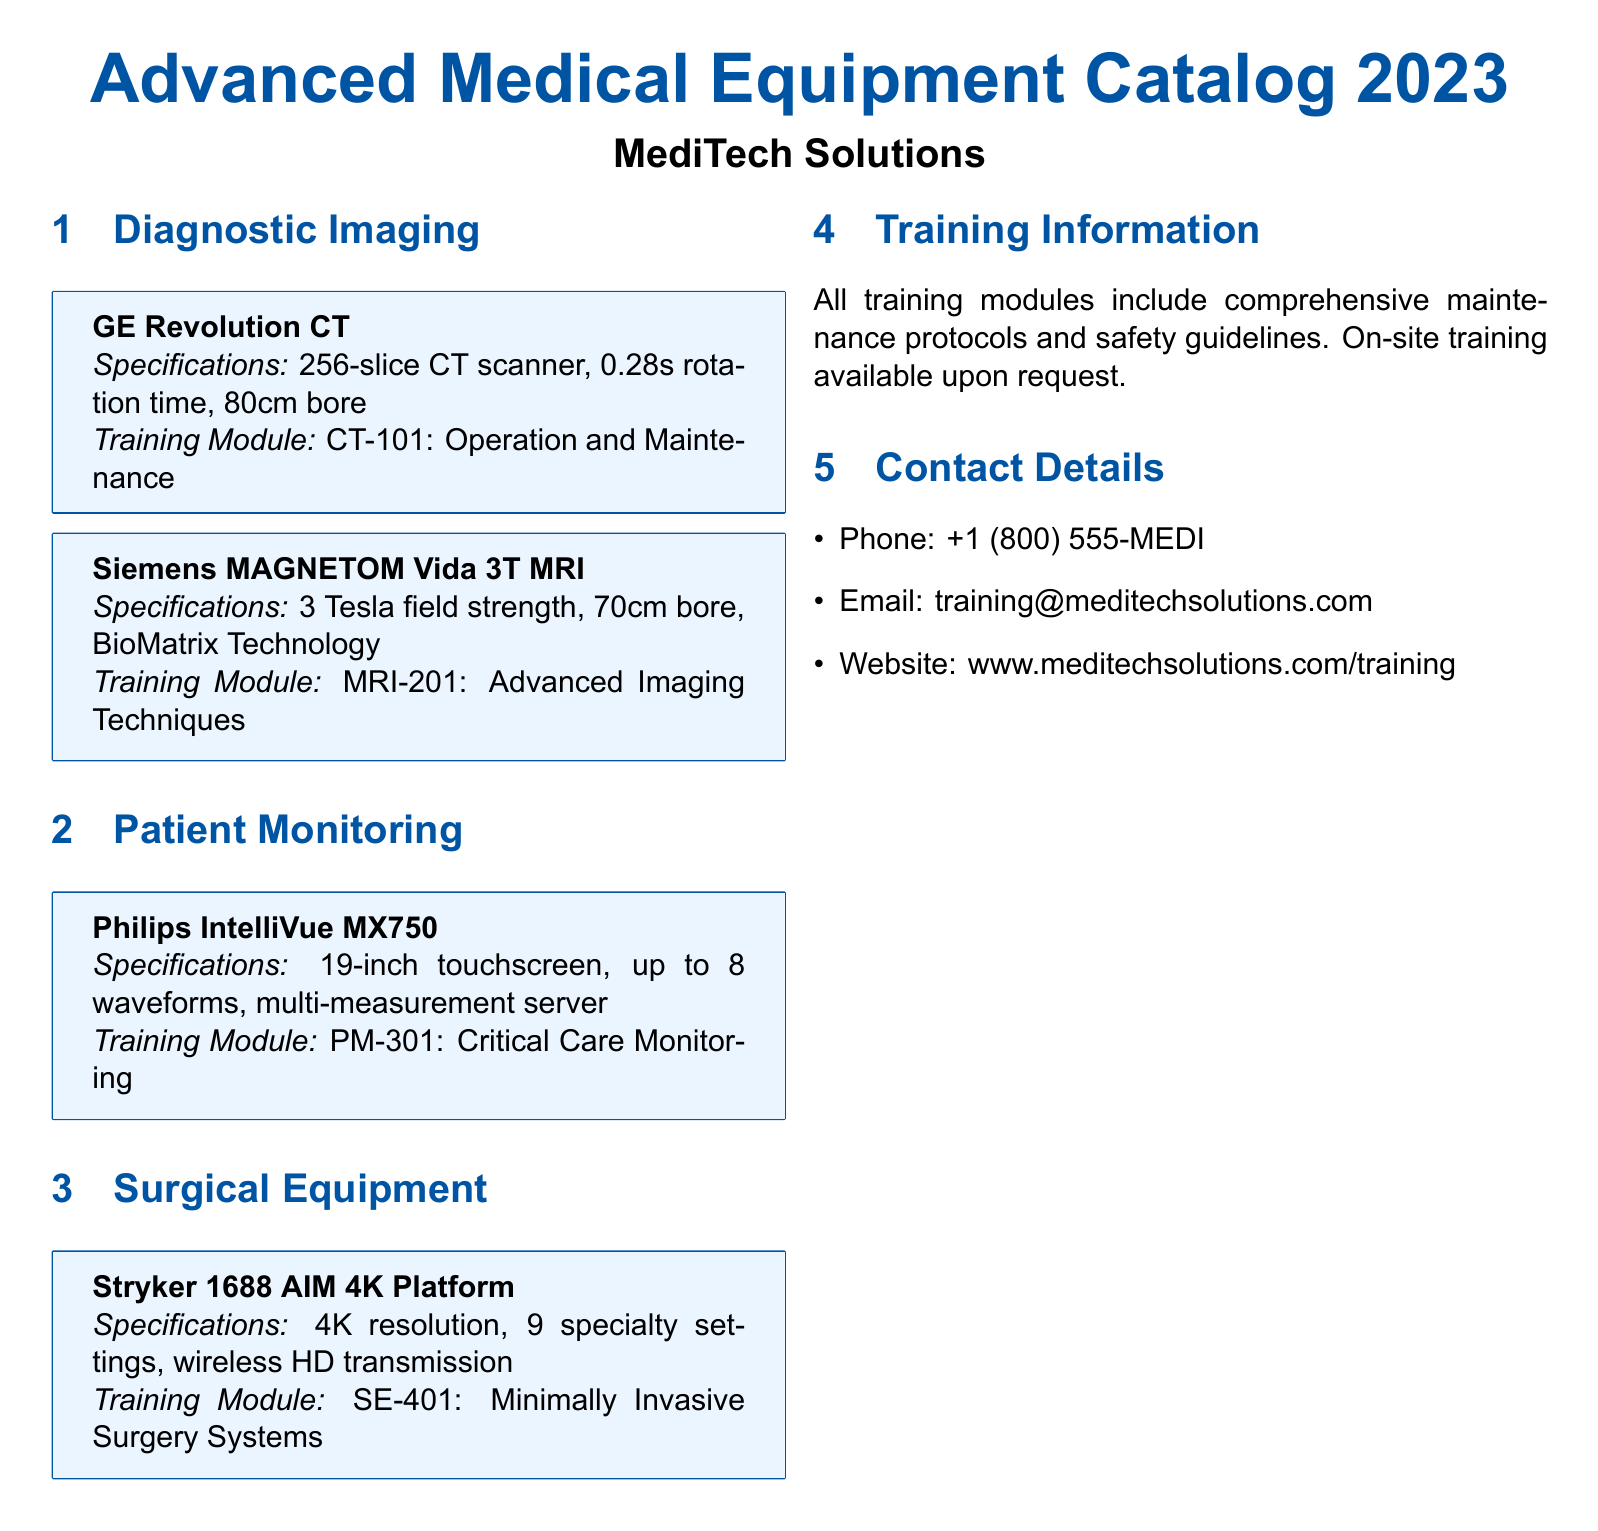What is the rotation time of GE Revolution CT? The rotation time of GE Revolution CT is specified as 0.28 seconds in the document.
Answer: 0.28s What is the field strength of Siemens MAGNETOM Vida 3T MRI? The document states that the field strength of this MRI device is 3 Tesla.
Answer: 3 Tesla How many waveforms can Philips IntelliVue MX750 monitor? According to the document, the Philips IntelliVue MX750 can monitor up to 8 waveforms.
Answer: 8 What type of training does the Stryker 1688 AIM 4K Platform include? The training module for this platform is described as focusing on Minimally Invasive Surgery Systems in the catalog.
Answer: Minimally Invasive Surgery Systems Is on-site training available? The document mentions that on-site training is available upon request.
Answer: Yes What type of product is listed under Patient Monitoring? The document identifies the Philips IntelliVue MX750 as a product under Patient Monitoring.
Answer: Philips IntelliVue MX750 Which company provides this catalog? The catalog is provided by MediTech Solutions as stated at the beginning of the document.
Answer: MediTech Solutions What specifications are included in the training modules? All training modules include comprehensive maintenance protocols and safety guidelines as specified in the document.
Answer: Maintenance protocols and safety guidelines What is the recommended training module for GE Revolution CT? The recommended training module for GE Revolution CT is CT-101: Operation and Maintenance, as specified in the document.
Answer: CT-101: Operation and Maintenance 